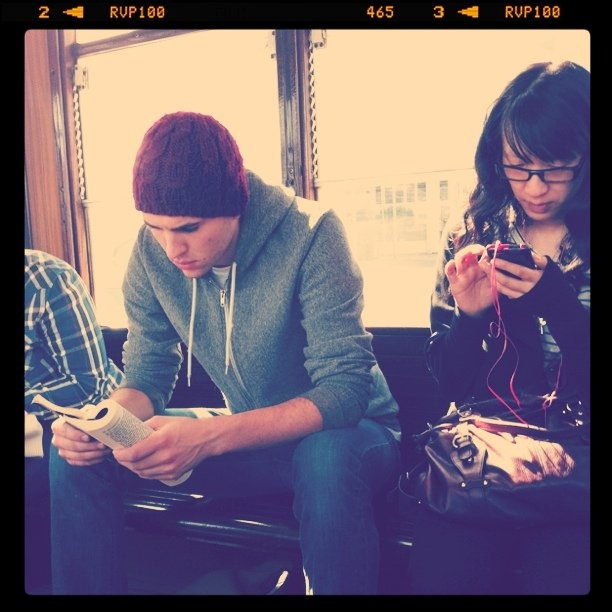Describe the objects in this image and their specific colors. I can see people in black, navy, gray, and darkblue tones, people in black, navy, purple, and lightpink tones, handbag in black, navy, purple, and tan tones, people in black, darkgray, gray, and blue tones, and book in black, tan, darkgray, and gray tones in this image. 